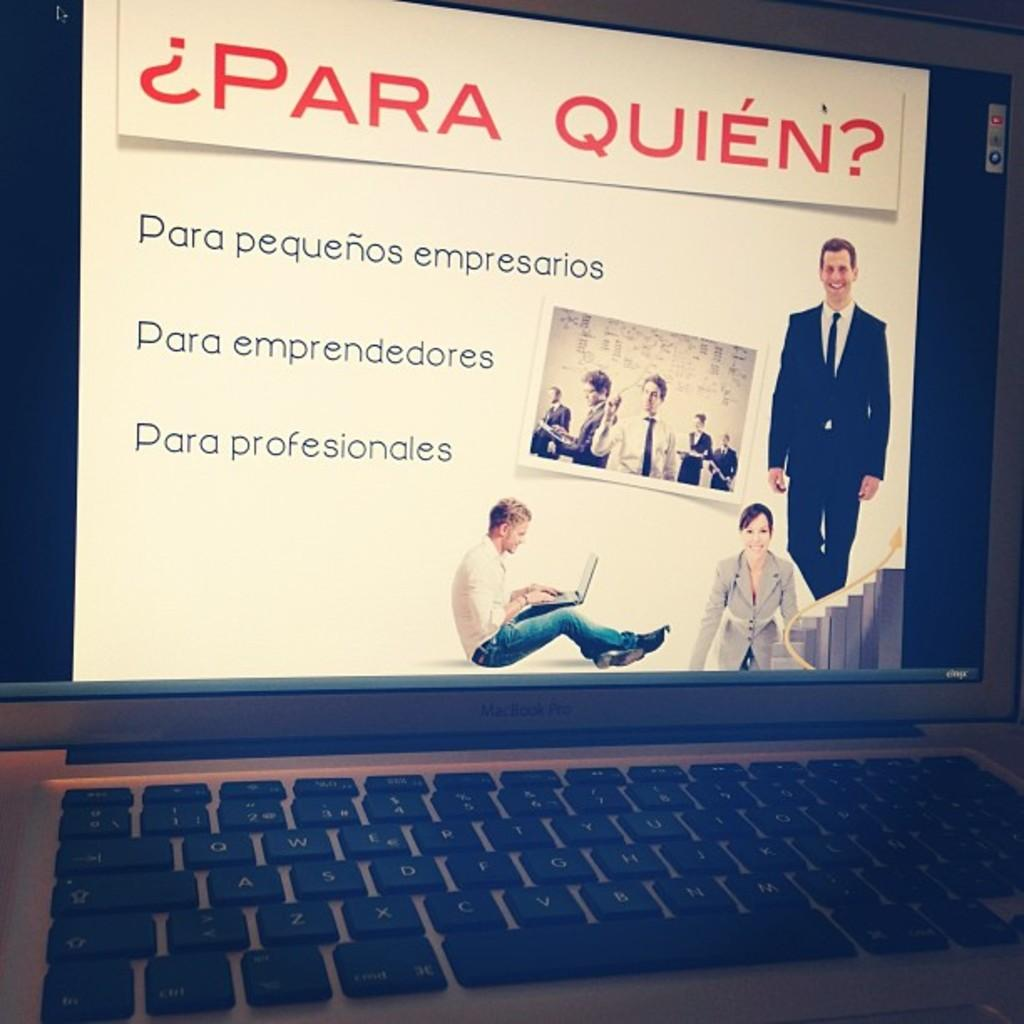What electronic device is visible in the image? There is a monitor screen in the image. What component is associated with the monitor screen in the image? There is a keypad in the image. What type of ray can be seen swimming in the image? There is no ray present in the image; it features a monitor screen and a keypad. What kind of drum is being played in the image? There is no drum present in the image; it features a monitor screen and a keypad. 